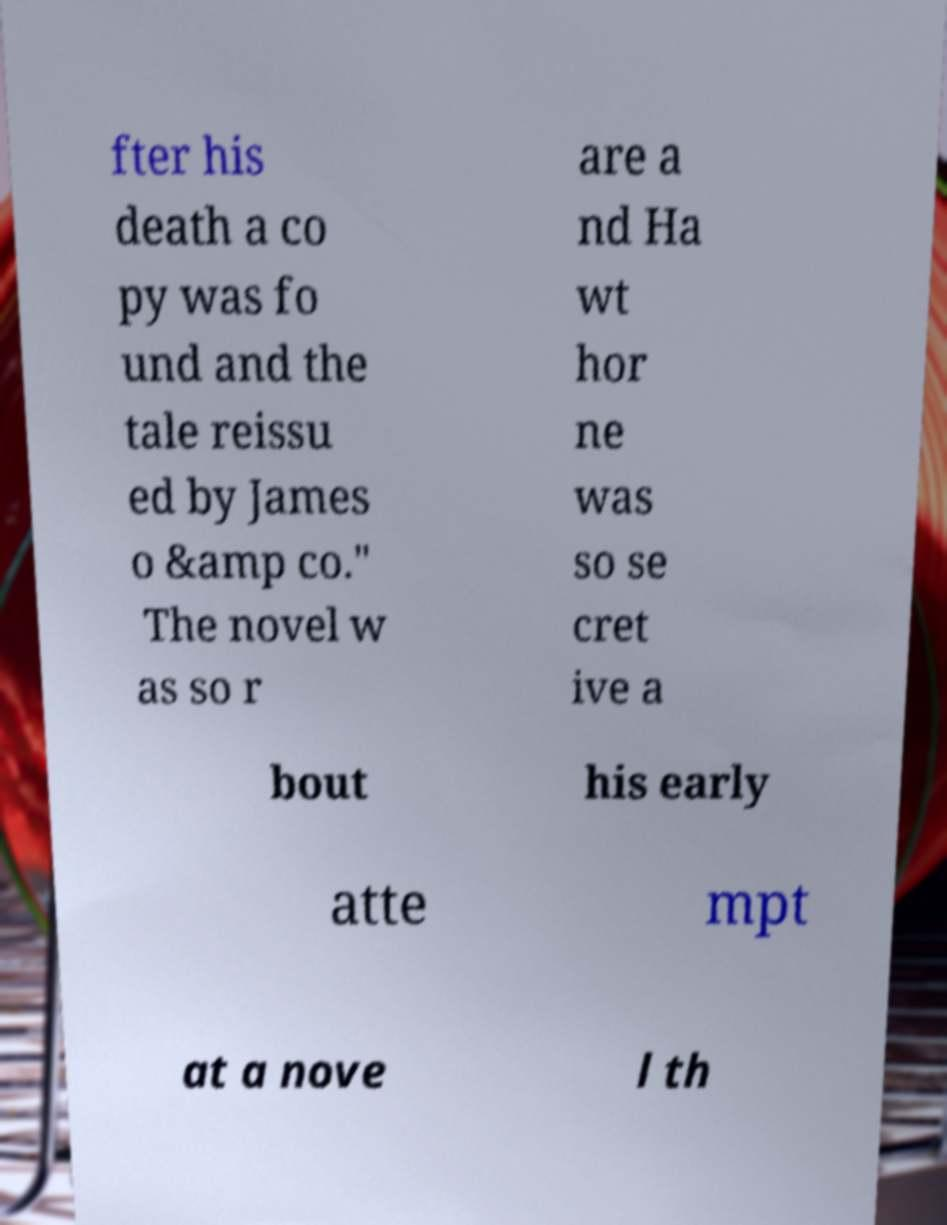Please read and relay the text visible in this image. What does it say? fter his death a co py was fo und and the tale reissu ed by James o &amp co." The novel w as so r are a nd Ha wt hor ne was so se cret ive a bout his early atte mpt at a nove l th 